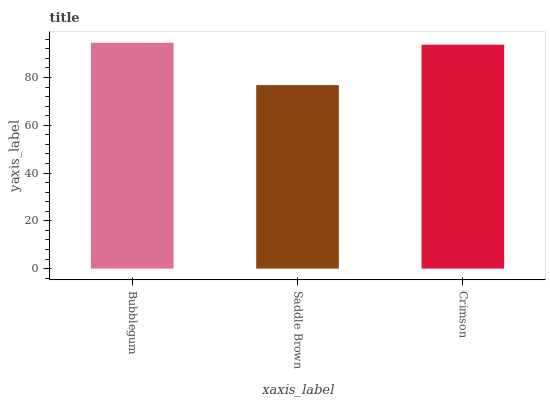Is Saddle Brown the minimum?
Answer yes or no. Yes. Is Bubblegum the maximum?
Answer yes or no. Yes. Is Crimson the minimum?
Answer yes or no. No. Is Crimson the maximum?
Answer yes or no. No. Is Crimson greater than Saddle Brown?
Answer yes or no. Yes. Is Saddle Brown less than Crimson?
Answer yes or no. Yes. Is Saddle Brown greater than Crimson?
Answer yes or no. No. Is Crimson less than Saddle Brown?
Answer yes or no. No. Is Crimson the high median?
Answer yes or no. Yes. Is Crimson the low median?
Answer yes or no. Yes. Is Saddle Brown the high median?
Answer yes or no. No. Is Saddle Brown the low median?
Answer yes or no. No. 